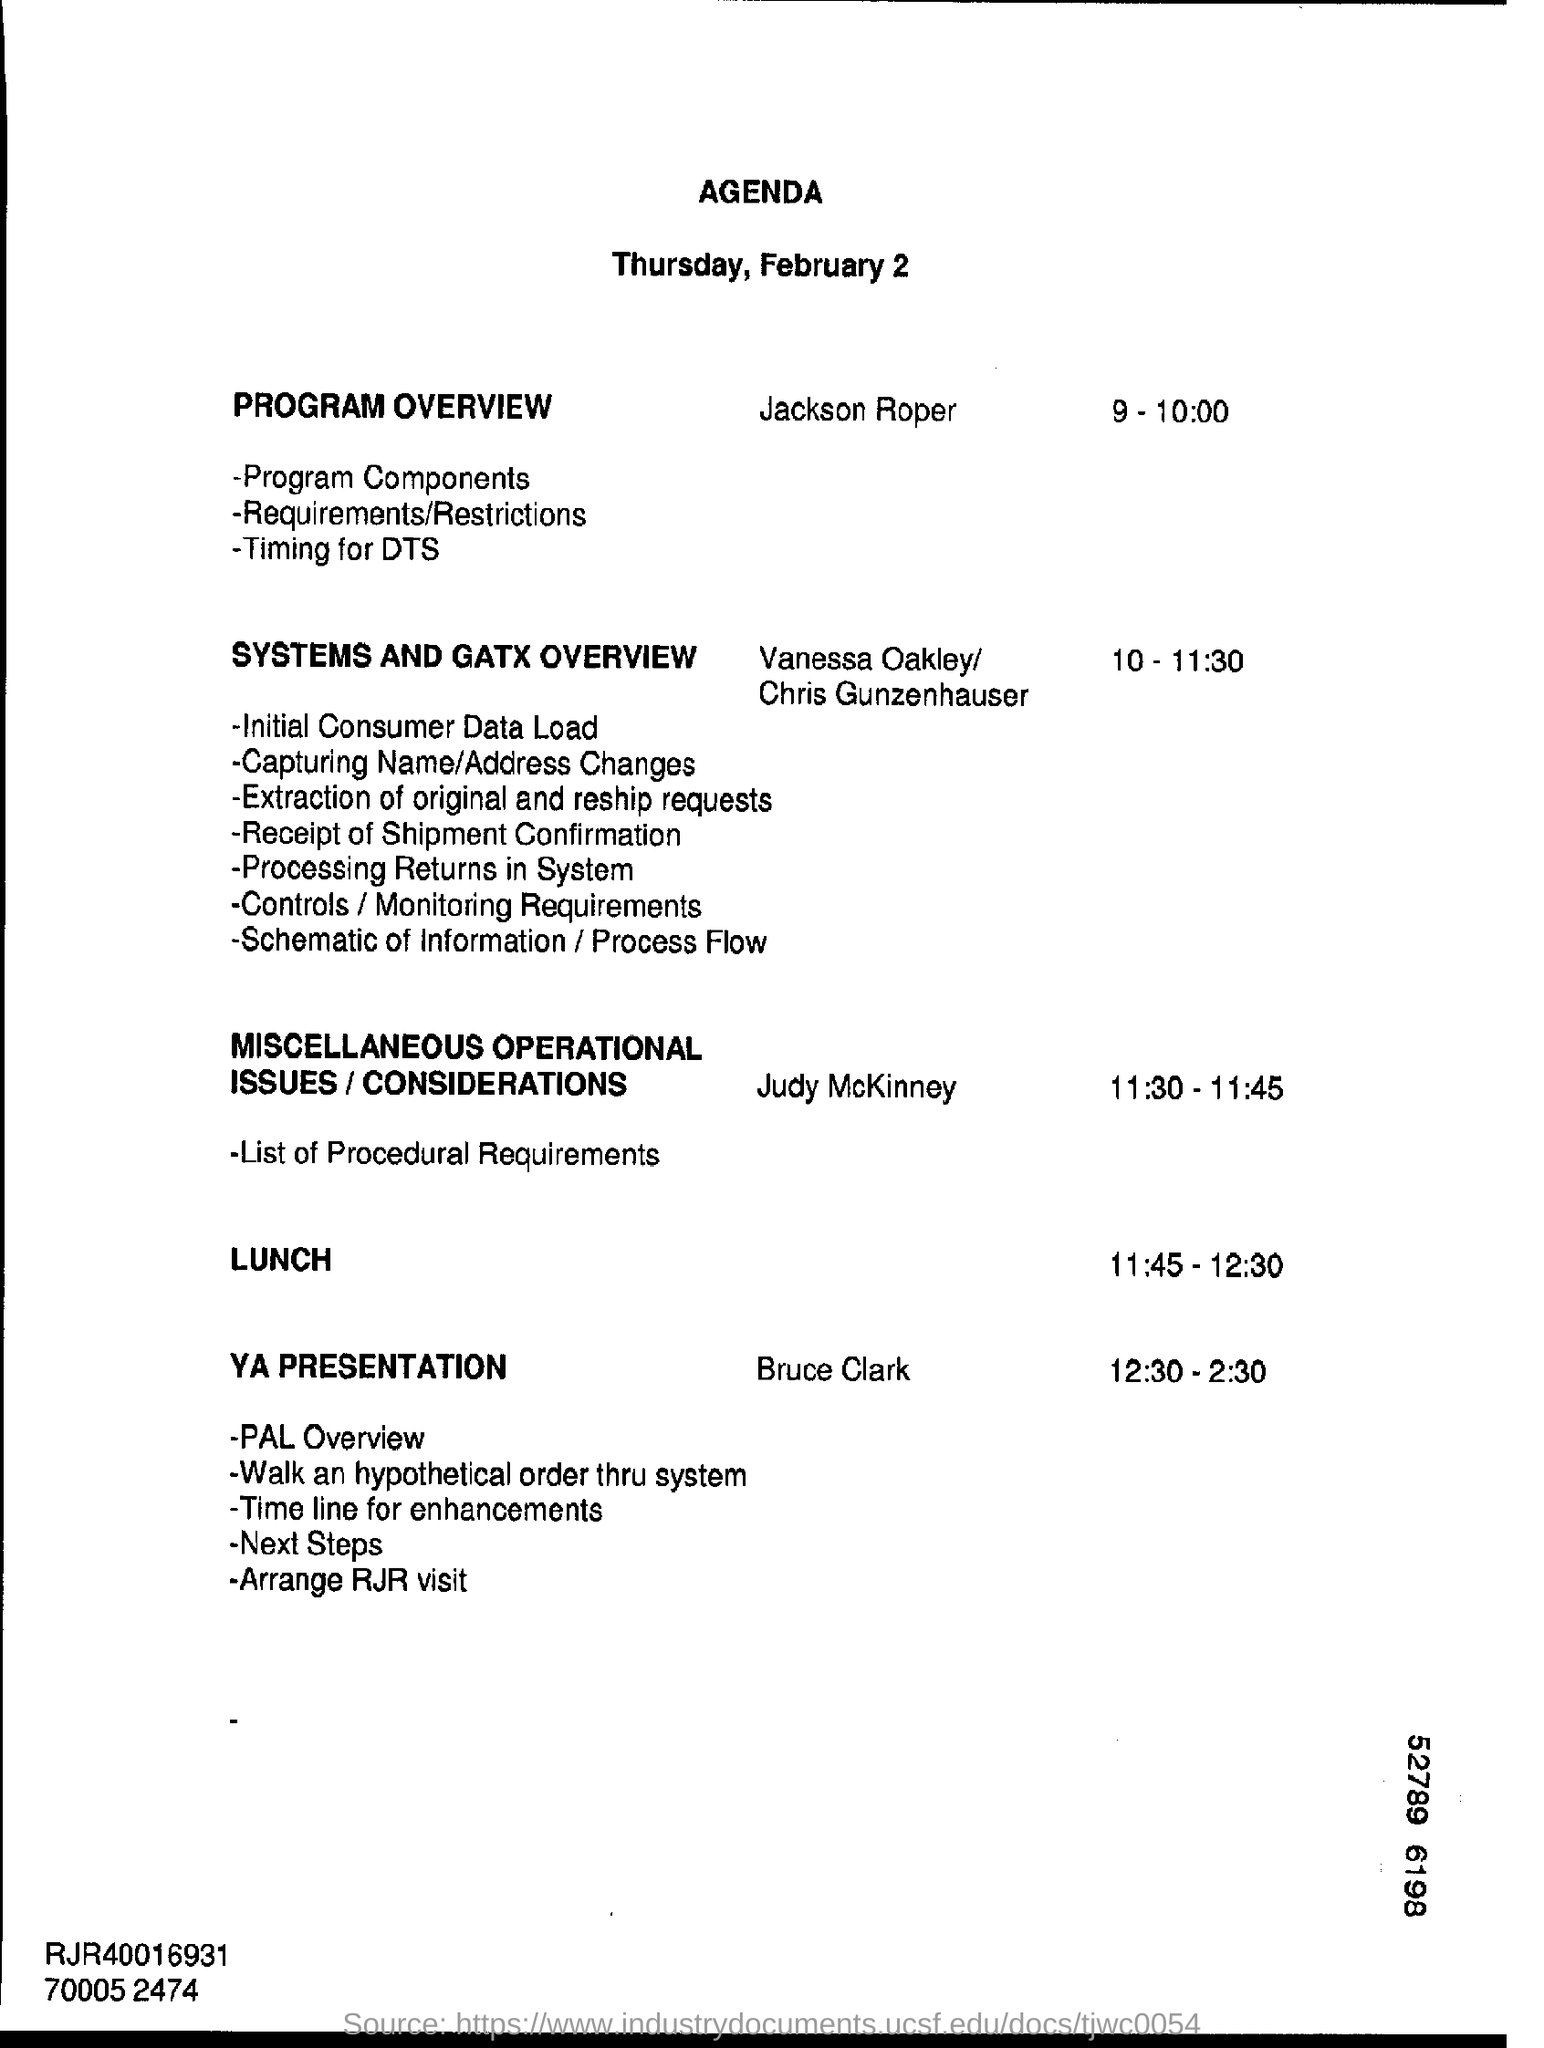Give some essential details in this illustration. The document mentions that the date is Thursday, February 2. 